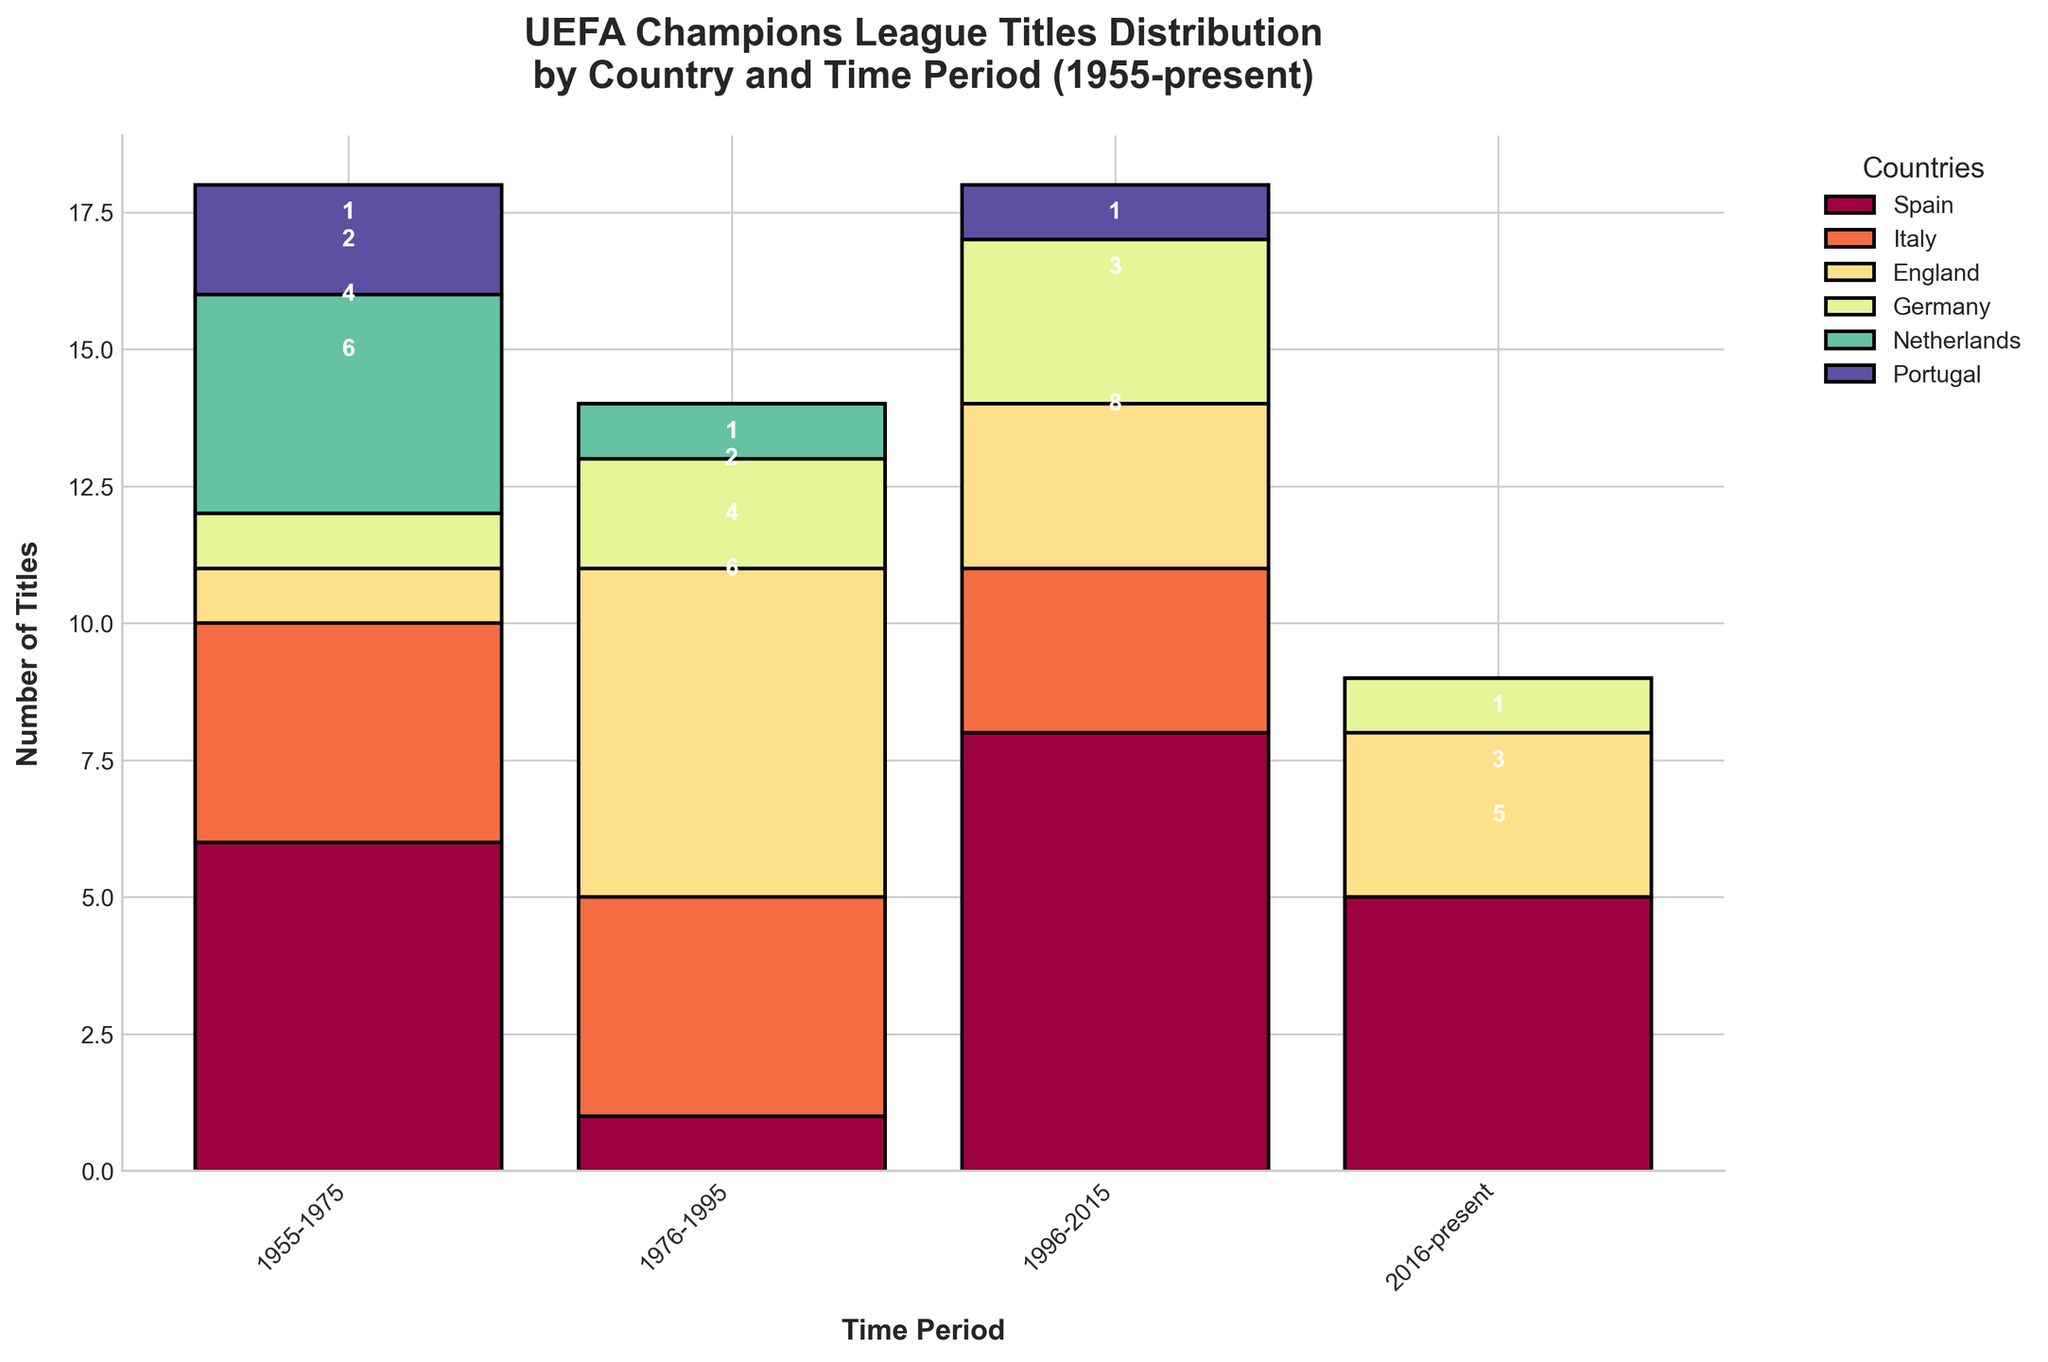What time period does the plot cover? The title of the plot mentions the time period, which is from 1955 to the present.
Answer: 1955 to present How many Champions League titles did Italy win in the period 1976-1995? By looking at the bar representing Italy in the 1976-1995 period, you can see that Italy won 4 titles.
Answer: 4 Which country won the most titles in the period 1996-2015? Comparing the bars for each country in the period 1996-2015, Spain has the tallest bar with 8 titles, which is the highest.
Answer: Spain How many total titles were won in the period 1955-1975? Sum the values for each country in the 1955-1975 period: Spain (6), Italy (4), England (1), Germany (1), Netherlands (4), and Portugal (2). This gives a total of 6 + 4 + 1 + 1 + 4 + 2 = 18.
Answer: 18 Which country has the largest increase in titles from one period to the next? Spain had 1 title in 1976-1995 and increased to 8 titles in 1996-2015, which is an increase of 7 titles, the largest among all countries.
Answer: Spain How many countries have won at least one title between 2016 and the present? Looking at the bars for the period 2016-present, Spain (5), England (3), and Germany (1) each have winning titles, so 3 countries in total.
Answer: 3 Which country, excluding Spain, had the most consistent performance across all periods? Italy maintained a fairly consistent performance with 4 titles in two periods and 3 in another, showing stable performance over time compared to other countries.
Answer: Italy How many titles did the Netherlands win in total between 1955 and the present? Sum all periods for the Netherlands: 4 (1955-1975), 1 (1976-1995), 0 (1996-2015), 0 (2016-present). So, 4 + 1 + 0 + 0 = 5 titles in total.
Answer: 5 In which period did Portugal win the highest number of titles? Observing Portugal's bars across all periods, the period 1955-1975 shows the highest with 2 titles.
Answer: 1955-1975 